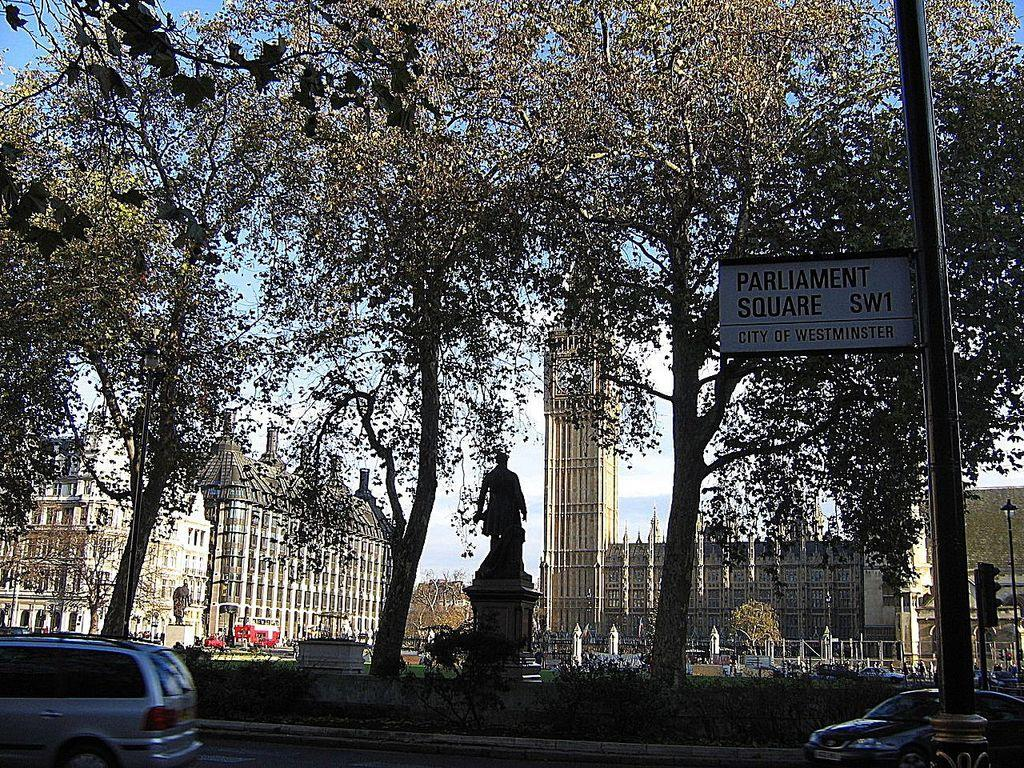What is happening on the road in the image? Cars are passing on the road in the image. What can be seen beside the cars on the road? There are trees beside the cars in the image. What is a notable feature in the image that is not a car or tree? There is a statue in the image. What can be seen in the distance behind the cars and trees? There are buildings in the background of the image. Can you see any wounds on the cars in the image? There are no wounds visible on the cars in the image, as cars do not have the ability to experience physical injuries. 